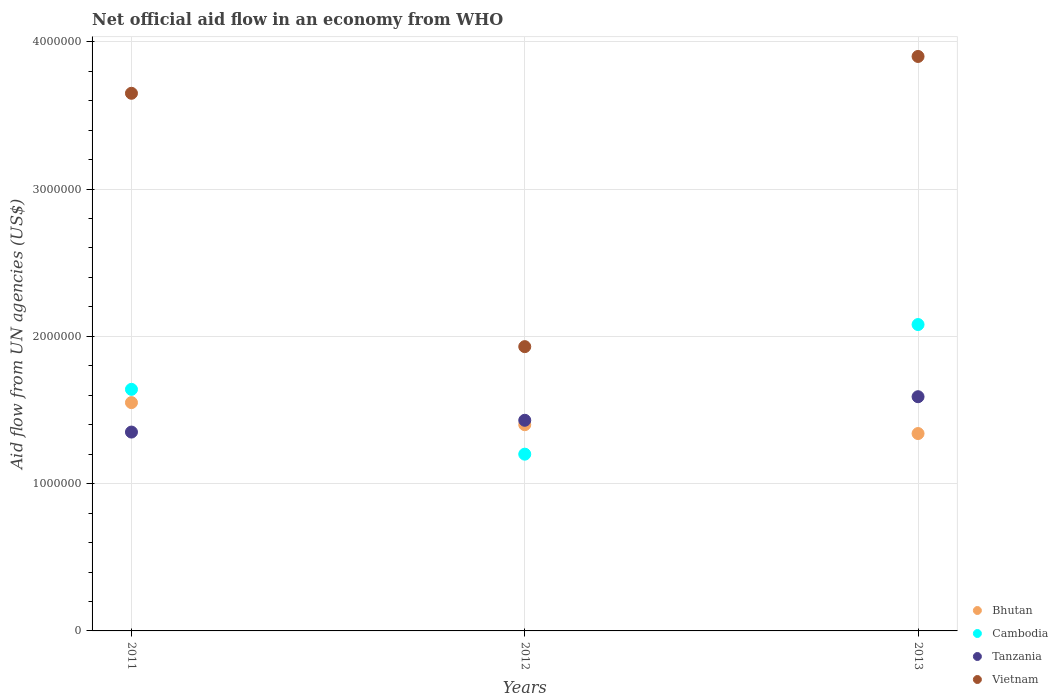What is the net official aid flow in Tanzania in 2013?
Provide a succinct answer. 1.59e+06. Across all years, what is the maximum net official aid flow in Vietnam?
Keep it short and to the point. 3.90e+06. Across all years, what is the minimum net official aid flow in Cambodia?
Offer a terse response. 1.20e+06. In which year was the net official aid flow in Bhutan maximum?
Provide a succinct answer. 2011. What is the total net official aid flow in Cambodia in the graph?
Give a very brief answer. 4.92e+06. What is the difference between the net official aid flow in Cambodia in 2012 and that in 2013?
Provide a short and direct response. -8.80e+05. What is the difference between the net official aid flow in Cambodia in 2011 and the net official aid flow in Tanzania in 2012?
Offer a terse response. 2.10e+05. What is the average net official aid flow in Bhutan per year?
Your answer should be very brief. 1.43e+06. In the year 2011, what is the difference between the net official aid flow in Cambodia and net official aid flow in Bhutan?
Offer a terse response. 9.00e+04. In how many years, is the net official aid flow in Bhutan greater than 600000 US$?
Keep it short and to the point. 3. What is the ratio of the net official aid flow in Bhutan in 2011 to that in 2013?
Ensure brevity in your answer.  1.16. Is the difference between the net official aid flow in Cambodia in 2011 and 2013 greater than the difference between the net official aid flow in Bhutan in 2011 and 2013?
Give a very brief answer. No. What is the difference between the highest and the second highest net official aid flow in Bhutan?
Provide a succinct answer. 1.50e+05. What is the difference between the highest and the lowest net official aid flow in Tanzania?
Keep it short and to the point. 2.40e+05. Is the sum of the net official aid flow in Tanzania in 2011 and 2012 greater than the maximum net official aid flow in Cambodia across all years?
Provide a short and direct response. Yes. How many dotlines are there?
Offer a very short reply. 4. How many years are there in the graph?
Ensure brevity in your answer.  3. What is the difference between two consecutive major ticks on the Y-axis?
Offer a terse response. 1.00e+06. Are the values on the major ticks of Y-axis written in scientific E-notation?
Give a very brief answer. No. Does the graph contain grids?
Make the answer very short. Yes. Where does the legend appear in the graph?
Give a very brief answer. Bottom right. What is the title of the graph?
Your response must be concise. Net official aid flow in an economy from WHO. Does "Burkina Faso" appear as one of the legend labels in the graph?
Make the answer very short. No. What is the label or title of the Y-axis?
Your response must be concise. Aid flow from UN agencies (US$). What is the Aid flow from UN agencies (US$) in Bhutan in 2011?
Keep it short and to the point. 1.55e+06. What is the Aid flow from UN agencies (US$) of Cambodia in 2011?
Offer a terse response. 1.64e+06. What is the Aid flow from UN agencies (US$) of Tanzania in 2011?
Your answer should be very brief. 1.35e+06. What is the Aid flow from UN agencies (US$) in Vietnam in 2011?
Keep it short and to the point. 3.65e+06. What is the Aid flow from UN agencies (US$) in Bhutan in 2012?
Provide a short and direct response. 1.40e+06. What is the Aid flow from UN agencies (US$) of Cambodia in 2012?
Make the answer very short. 1.20e+06. What is the Aid flow from UN agencies (US$) of Tanzania in 2012?
Ensure brevity in your answer.  1.43e+06. What is the Aid flow from UN agencies (US$) in Vietnam in 2012?
Keep it short and to the point. 1.93e+06. What is the Aid flow from UN agencies (US$) of Bhutan in 2013?
Your response must be concise. 1.34e+06. What is the Aid flow from UN agencies (US$) in Cambodia in 2013?
Ensure brevity in your answer.  2.08e+06. What is the Aid flow from UN agencies (US$) in Tanzania in 2013?
Ensure brevity in your answer.  1.59e+06. What is the Aid flow from UN agencies (US$) in Vietnam in 2013?
Your response must be concise. 3.90e+06. Across all years, what is the maximum Aid flow from UN agencies (US$) of Bhutan?
Your response must be concise. 1.55e+06. Across all years, what is the maximum Aid flow from UN agencies (US$) of Cambodia?
Your answer should be compact. 2.08e+06. Across all years, what is the maximum Aid flow from UN agencies (US$) of Tanzania?
Give a very brief answer. 1.59e+06. Across all years, what is the maximum Aid flow from UN agencies (US$) in Vietnam?
Give a very brief answer. 3.90e+06. Across all years, what is the minimum Aid flow from UN agencies (US$) of Bhutan?
Your answer should be very brief. 1.34e+06. Across all years, what is the minimum Aid flow from UN agencies (US$) of Cambodia?
Ensure brevity in your answer.  1.20e+06. Across all years, what is the minimum Aid flow from UN agencies (US$) in Tanzania?
Offer a terse response. 1.35e+06. Across all years, what is the minimum Aid flow from UN agencies (US$) in Vietnam?
Provide a short and direct response. 1.93e+06. What is the total Aid flow from UN agencies (US$) in Bhutan in the graph?
Make the answer very short. 4.29e+06. What is the total Aid flow from UN agencies (US$) in Cambodia in the graph?
Offer a terse response. 4.92e+06. What is the total Aid flow from UN agencies (US$) in Tanzania in the graph?
Your answer should be compact. 4.37e+06. What is the total Aid flow from UN agencies (US$) of Vietnam in the graph?
Provide a short and direct response. 9.48e+06. What is the difference between the Aid flow from UN agencies (US$) of Bhutan in 2011 and that in 2012?
Give a very brief answer. 1.50e+05. What is the difference between the Aid flow from UN agencies (US$) in Cambodia in 2011 and that in 2012?
Provide a succinct answer. 4.40e+05. What is the difference between the Aid flow from UN agencies (US$) of Tanzania in 2011 and that in 2012?
Provide a succinct answer. -8.00e+04. What is the difference between the Aid flow from UN agencies (US$) of Vietnam in 2011 and that in 2012?
Your response must be concise. 1.72e+06. What is the difference between the Aid flow from UN agencies (US$) in Bhutan in 2011 and that in 2013?
Your response must be concise. 2.10e+05. What is the difference between the Aid flow from UN agencies (US$) of Cambodia in 2011 and that in 2013?
Offer a terse response. -4.40e+05. What is the difference between the Aid flow from UN agencies (US$) of Vietnam in 2011 and that in 2013?
Provide a succinct answer. -2.50e+05. What is the difference between the Aid flow from UN agencies (US$) of Cambodia in 2012 and that in 2013?
Provide a succinct answer. -8.80e+05. What is the difference between the Aid flow from UN agencies (US$) in Vietnam in 2012 and that in 2013?
Your answer should be very brief. -1.97e+06. What is the difference between the Aid flow from UN agencies (US$) of Bhutan in 2011 and the Aid flow from UN agencies (US$) of Tanzania in 2012?
Ensure brevity in your answer.  1.20e+05. What is the difference between the Aid flow from UN agencies (US$) in Bhutan in 2011 and the Aid flow from UN agencies (US$) in Vietnam in 2012?
Make the answer very short. -3.80e+05. What is the difference between the Aid flow from UN agencies (US$) in Cambodia in 2011 and the Aid flow from UN agencies (US$) in Tanzania in 2012?
Your answer should be very brief. 2.10e+05. What is the difference between the Aid flow from UN agencies (US$) of Tanzania in 2011 and the Aid flow from UN agencies (US$) of Vietnam in 2012?
Provide a succinct answer. -5.80e+05. What is the difference between the Aid flow from UN agencies (US$) in Bhutan in 2011 and the Aid flow from UN agencies (US$) in Cambodia in 2013?
Offer a terse response. -5.30e+05. What is the difference between the Aid flow from UN agencies (US$) of Bhutan in 2011 and the Aid flow from UN agencies (US$) of Vietnam in 2013?
Offer a terse response. -2.35e+06. What is the difference between the Aid flow from UN agencies (US$) of Cambodia in 2011 and the Aid flow from UN agencies (US$) of Tanzania in 2013?
Your answer should be very brief. 5.00e+04. What is the difference between the Aid flow from UN agencies (US$) of Cambodia in 2011 and the Aid flow from UN agencies (US$) of Vietnam in 2013?
Keep it short and to the point. -2.26e+06. What is the difference between the Aid flow from UN agencies (US$) in Tanzania in 2011 and the Aid flow from UN agencies (US$) in Vietnam in 2013?
Offer a terse response. -2.55e+06. What is the difference between the Aid flow from UN agencies (US$) in Bhutan in 2012 and the Aid flow from UN agencies (US$) in Cambodia in 2013?
Offer a very short reply. -6.80e+05. What is the difference between the Aid flow from UN agencies (US$) of Bhutan in 2012 and the Aid flow from UN agencies (US$) of Tanzania in 2013?
Your answer should be very brief. -1.90e+05. What is the difference between the Aid flow from UN agencies (US$) in Bhutan in 2012 and the Aid flow from UN agencies (US$) in Vietnam in 2013?
Offer a very short reply. -2.50e+06. What is the difference between the Aid flow from UN agencies (US$) in Cambodia in 2012 and the Aid flow from UN agencies (US$) in Tanzania in 2013?
Your answer should be very brief. -3.90e+05. What is the difference between the Aid flow from UN agencies (US$) in Cambodia in 2012 and the Aid flow from UN agencies (US$) in Vietnam in 2013?
Ensure brevity in your answer.  -2.70e+06. What is the difference between the Aid flow from UN agencies (US$) of Tanzania in 2012 and the Aid flow from UN agencies (US$) of Vietnam in 2013?
Provide a succinct answer. -2.47e+06. What is the average Aid flow from UN agencies (US$) in Bhutan per year?
Your response must be concise. 1.43e+06. What is the average Aid flow from UN agencies (US$) of Cambodia per year?
Your answer should be very brief. 1.64e+06. What is the average Aid flow from UN agencies (US$) in Tanzania per year?
Offer a very short reply. 1.46e+06. What is the average Aid flow from UN agencies (US$) in Vietnam per year?
Your response must be concise. 3.16e+06. In the year 2011, what is the difference between the Aid flow from UN agencies (US$) in Bhutan and Aid flow from UN agencies (US$) in Tanzania?
Offer a terse response. 2.00e+05. In the year 2011, what is the difference between the Aid flow from UN agencies (US$) of Bhutan and Aid flow from UN agencies (US$) of Vietnam?
Provide a short and direct response. -2.10e+06. In the year 2011, what is the difference between the Aid flow from UN agencies (US$) in Cambodia and Aid flow from UN agencies (US$) in Vietnam?
Provide a short and direct response. -2.01e+06. In the year 2011, what is the difference between the Aid flow from UN agencies (US$) in Tanzania and Aid flow from UN agencies (US$) in Vietnam?
Offer a very short reply. -2.30e+06. In the year 2012, what is the difference between the Aid flow from UN agencies (US$) of Bhutan and Aid flow from UN agencies (US$) of Cambodia?
Make the answer very short. 2.00e+05. In the year 2012, what is the difference between the Aid flow from UN agencies (US$) in Bhutan and Aid flow from UN agencies (US$) in Vietnam?
Offer a terse response. -5.30e+05. In the year 2012, what is the difference between the Aid flow from UN agencies (US$) in Cambodia and Aid flow from UN agencies (US$) in Tanzania?
Make the answer very short. -2.30e+05. In the year 2012, what is the difference between the Aid flow from UN agencies (US$) of Cambodia and Aid flow from UN agencies (US$) of Vietnam?
Give a very brief answer. -7.30e+05. In the year 2012, what is the difference between the Aid flow from UN agencies (US$) of Tanzania and Aid flow from UN agencies (US$) of Vietnam?
Give a very brief answer. -5.00e+05. In the year 2013, what is the difference between the Aid flow from UN agencies (US$) in Bhutan and Aid flow from UN agencies (US$) in Cambodia?
Make the answer very short. -7.40e+05. In the year 2013, what is the difference between the Aid flow from UN agencies (US$) in Bhutan and Aid flow from UN agencies (US$) in Vietnam?
Ensure brevity in your answer.  -2.56e+06. In the year 2013, what is the difference between the Aid flow from UN agencies (US$) of Cambodia and Aid flow from UN agencies (US$) of Tanzania?
Your response must be concise. 4.90e+05. In the year 2013, what is the difference between the Aid flow from UN agencies (US$) in Cambodia and Aid flow from UN agencies (US$) in Vietnam?
Offer a terse response. -1.82e+06. In the year 2013, what is the difference between the Aid flow from UN agencies (US$) of Tanzania and Aid flow from UN agencies (US$) of Vietnam?
Offer a very short reply. -2.31e+06. What is the ratio of the Aid flow from UN agencies (US$) of Bhutan in 2011 to that in 2012?
Make the answer very short. 1.11. What is the ratio of the Aid flow from UN agencies (US$) of Cambodia in 2011 to that in 2012?
Your answer should be very brief. 1.37. What is the ratio of the Aid flow from UN agencies (US$) of Tanzania in 2011 to that in 2012?
Your answer should be compact. 0.94. What is the ratio of the Aid flow from UN agencies (US$) in Vietnam in 2011 to that in 2012?
Provide a short and direct response. 1.89. What is the ratio of the Aid flow from UN agencies (US$) of Bhutan in 2011 to that in 2013?
Offer a terse response. 1.16. What is the ratio of the Aid flow from UN agencies (US$) of Cambodia in 2011 to that in 2013?
Offer a terse response. 0.79. What is the ratio of the Aid flow from UN agencies (US$) of Tanzania in 2011 to that in 2013?
Ensure brevity in your answer.  0.85. What is the ratio of the Aid flow from UN agencies (US$) of Vietnam in 2011 to that in 2013?
Make the answer very short. 0.94. What is the ratio of the Aid flow from UN agencies (US$) in Bhutan in 2012 to that in 2013?
Your answer should be compact. 1.04. What is the ratio of the Aid flow from UN agencies (US$) of Cambodia in 2012 to that in 2013?
Give a very brief answer. 0.58. What is the ratio of the Aid flow from UN agencies (US$) in Tanzania in 2012 to that in 2013?
Give a very brief answer. 0.9. What is the ratio of the Aid flow from UN agencies (US$) in Vietnam in 2012 to that in 2013?
Ensure brevity in your answer.  0.49. What is the difference between the highest and the second highest Aid flow from UN agencies (US$) in Bhutan?
Your answer should be very brief. 1.50e+05. What is the difference between the highest and the second highest Aid flow from UN agencies (US$) of Tanzania?
Give a very brief answer. 1.60e+05. What is the difference between the highest and the lowest Aid flow from UN agencies (US$) in Cambodia?
Offer a very short reply. 8.80e+05. What is the difference between the highest and the lowest Aid flow from UN agencies (US$) in Vietnam?
Offer a terse response. 1.97e+06. 